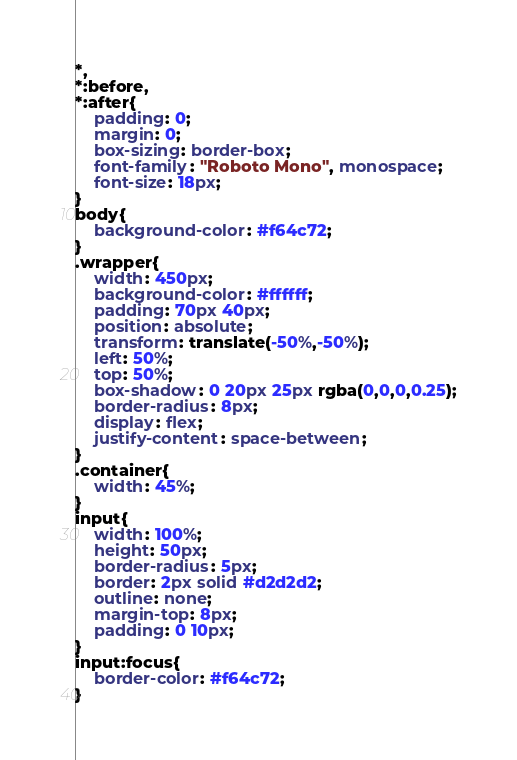Convert code to text. <code><loc_0><loc_0><loc_500><loc_500><_CSS_>*,
*:before,
*:after{
    padding: 0;
    margin: 0;
    box-sizing: border-box;
    font-family: "Roboto Mono", monospace;
    font-size: 18px;
}
body{
    background-color: #f64c72;
}
.wrapper{
    width: 450px;
    background-color: #ffffff;
    padding: 70px 40px;
    position: absolute;
    transform: translate(-50%,-50%);
    left: 50%;
    top: 50%;
    box-shadow: 0 20px 25px rgba(0,0,0,0.25);
    border-radius: 8px;
    display: flex;
    justify-content: space-between;
}
.container{
    width: 45%;
}
input{
    width: 100%;
    height: 50px;
    border-radius: 5px;
    border: 2px solid #d2d2d2;
    outline: none;
    margin-top: 8px;
    padding: 0 10px;
}
input:focus{
    border-color: #f64c72;
}</code> 